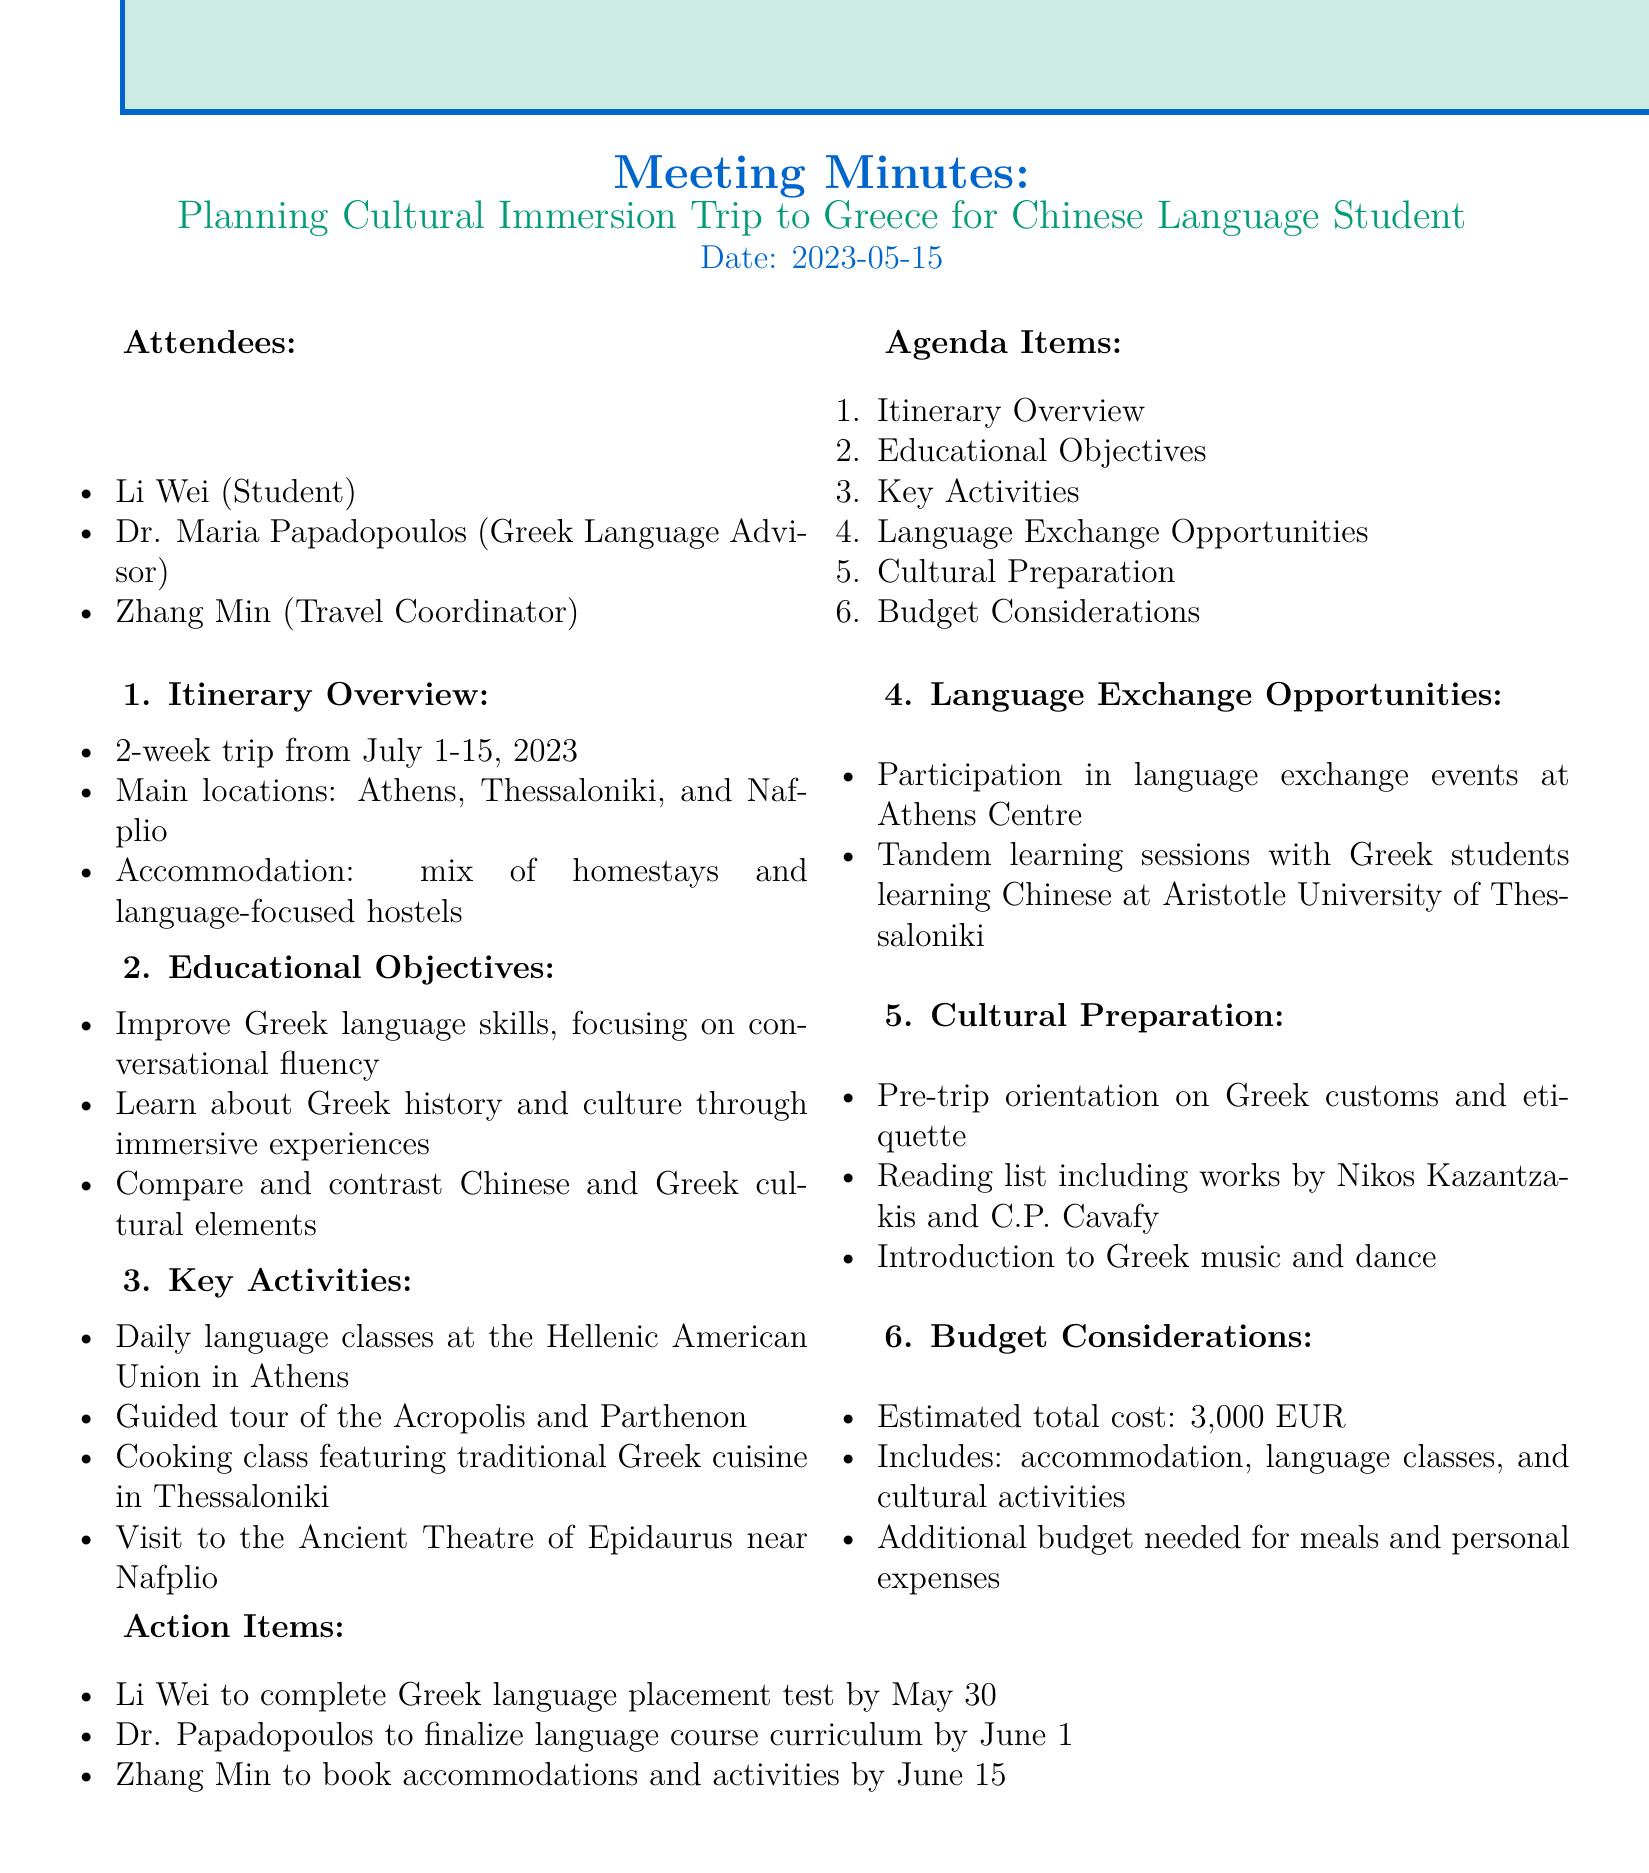What are the main locations for the trip? The document lists the main locations as Athens, Thessaloniki, and Nafplio.
Answer: Athens, Thessaloniki, Nafplio What is the estimated total cost of the trip? The estimated total cost mentioned in the document is 3,000 EUR.
Answer: 3,000 EUR What dates is the trip scheduled for? The trip is scheduled to take place from July 1 to July 15, 2023.
Answer: July 1-15, 2023 Who is responsible for booking accommodations? The action item for booking accommodations is assigned to Zhang Min.
Answer: Zhang Min What is one of the educational objectives of the trip? One of the educational objectives stated in the document is to improve Greek language skills, focusing on conversational fluency.
Answer: Improve Greek language skills What type of accommodation will be used during the trip? The document states that the accommodation will be a mix of homestays and language-focused hostels.
Answer: Homestays and language-focused hostels What is one key activity planned in Thessaloniki? A cooking class featuring traditional Greek cuisine is planned as a key activity in Thessaloniki.
Answer: Cooking class What should Li Wei complete by May 30? Li Wei is required to complete the Greek language placement test by May 30.
Answer: Greek language placement test What is included in the budget considerations? The budget considerations include accommodation, language classes, and cultural activities.
Answer: Accommodation, language classes, cultural activities 